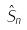<formula> <loc_0><loc_0><loc_500><loc_500>\hat { S } _ { n }</formula> 